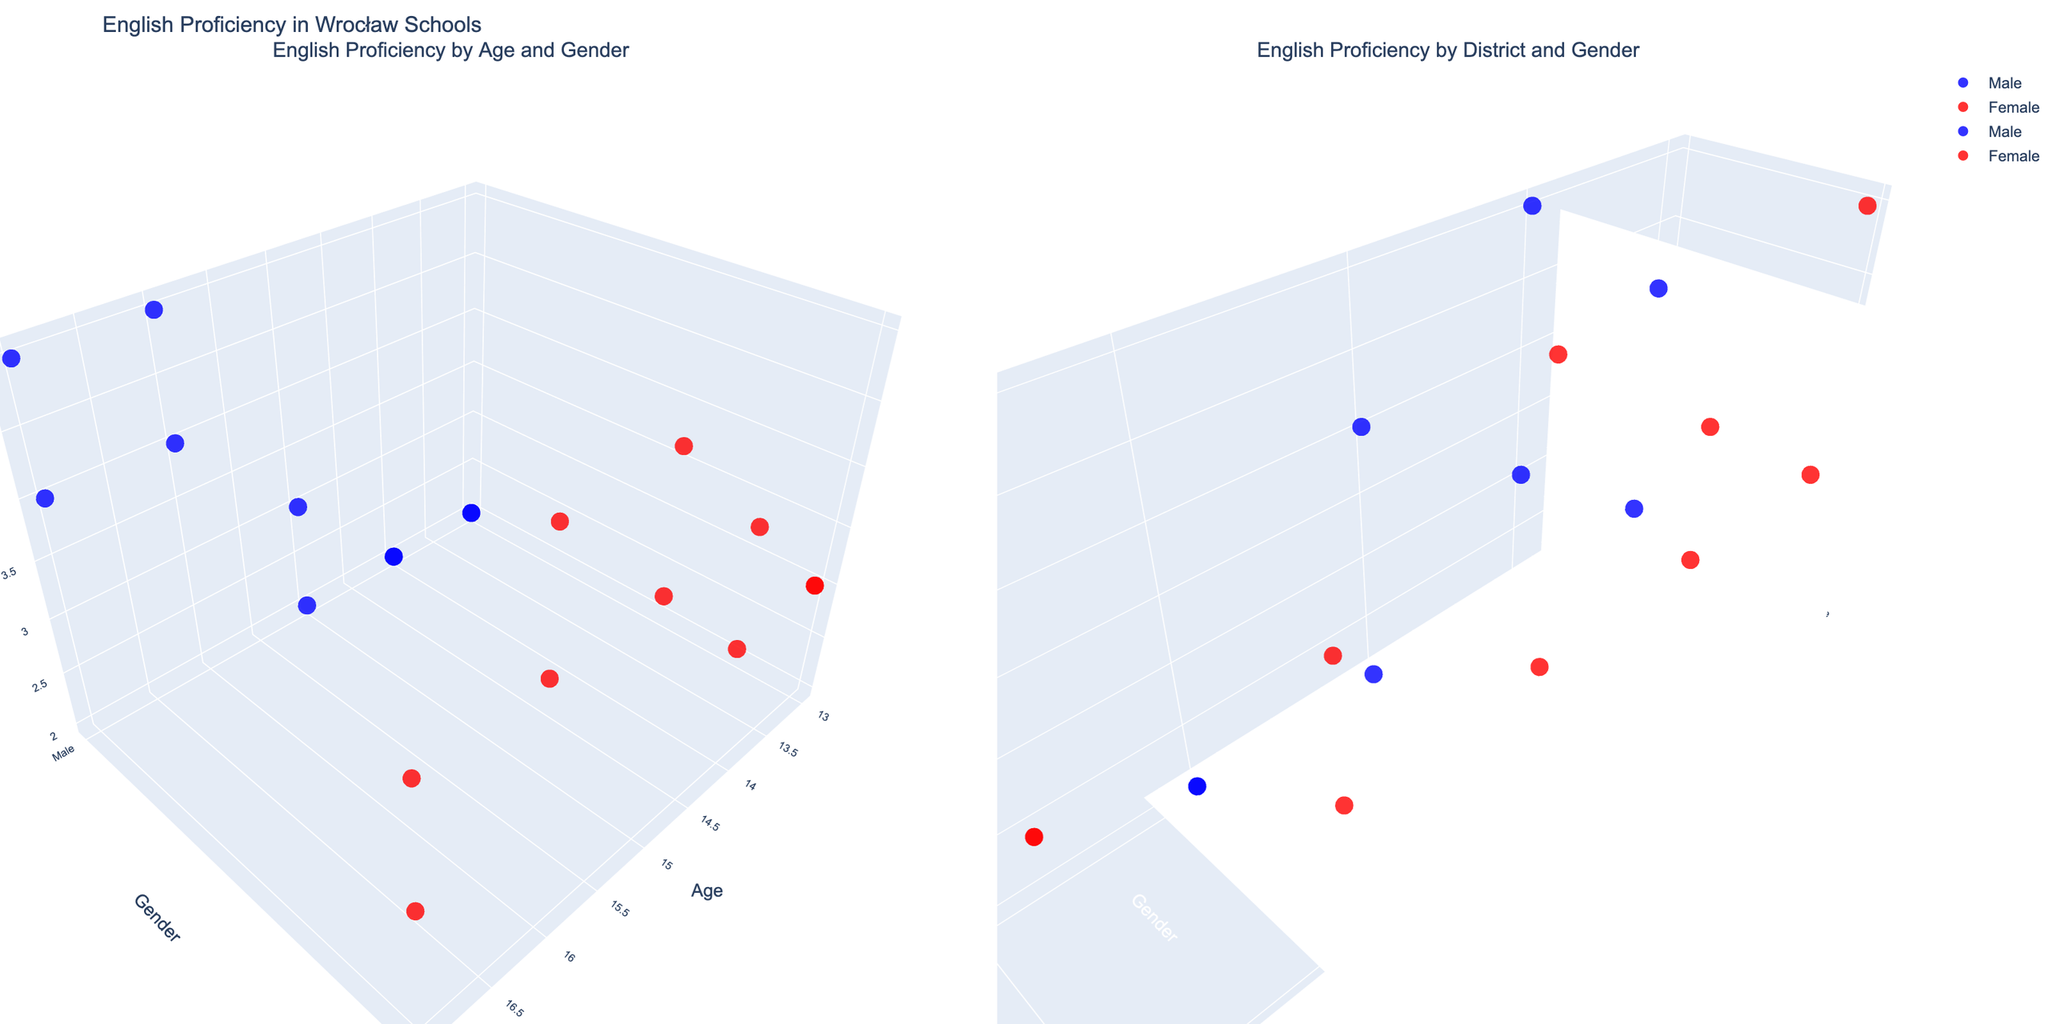What's the title of the figure? The title of the figure is usually displayed at the top and provides a succinct summary of what the figure represents. According to the code, the title should be "English Proficiency in Wrocław Schools".
Answer: English Proficiency in Wrocław Schools What are the x-axis labels for the plot showing English proficiency by age and gender? The x-axis labels for the first plot correspond to the "Age" of the students, as indicated by the code that sets the x-axis title to "Age".
Answer: Age How does the proficiency level compare between males and females in the Krzyki district? To compare proficiency levels between genders in Krzyki, identify the points in the second sub-plot for 'Krzyki'. Females are represented by red markers and males by blue markers. The red marker is at level B1, and the blue marker is at level A2. This shows that females in Krzyki have a higher proficiency level than males.
Answer: Females are higher than males Which age group shows the highest proficiency level among the females? To find the highest proficiency level among females, look for the highest values (z-axis) with female gender (red markers) in the first plot. The highest proficiency level (C1) is at age 15.
Answer: 15 Which district has the highest observed proficiency level and which gender shows this level? Look at the second plot and identify the highest z-value, which corresponds to proficiency C1. This point is red, indicating it belongs to a female, and the district is Fabryczna.
Answer: Fabryczna, Female How many data points are plotted in each subplot? The data points in each subplot are individually added based on whether they are male or female, with 10 data points per gender in the Dataset. Thus, both subplots will have 20 data points each.
Answer: 20 For the age group 16, which gender has a higher proficiency level? In the first plot, locate the markers at age 16. Compare the z-values of the red marker (female) and the blue marker (male). The female marker is at proficiency C1, and the male marker is at proficiency B2, indicating that females have a higher proficiency level at age 16.
Answer: Female In which district do males achieve the proficiency level of C1, and what is the age group of these students? In the second plot, note where blue markers (males) achieve the highest z-value (C1). The district is Stare Miasto. We can cross-reference this with the first plot to find the corresponding age, which is 17 years.
Answer: Stare Miasto, 17 What proficiency levels do female students show in Śródmieście? In the first plot, locate points representing female students (red markers) with the district of Śródmieście. The proficiency levels for these students are B2, B1 (ages 15 and 17 respectively).
Answer: B2, B1 